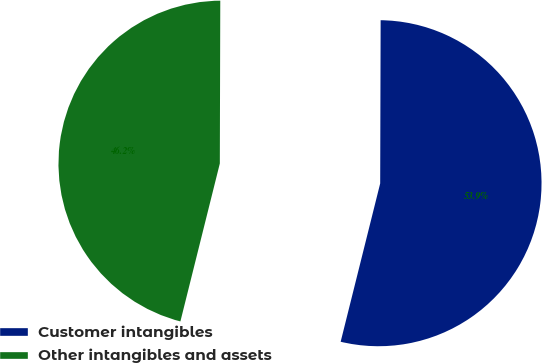Convert chart to OTSL. <chart><loc_0><loc_0><loc_500><loc_500><pie_chart><fcel>Customer intangibles<fcel>Other intangibles and assets<nl><fcel>53.85%<fcel>46.15%<nl></chart> 